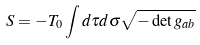<formula> <loc_0><loc_0><loc_500><loc_500>S = - T _ { 0 } \int d \tau d \sigma \sqrt { - \det g _ { a b } }</formula> 